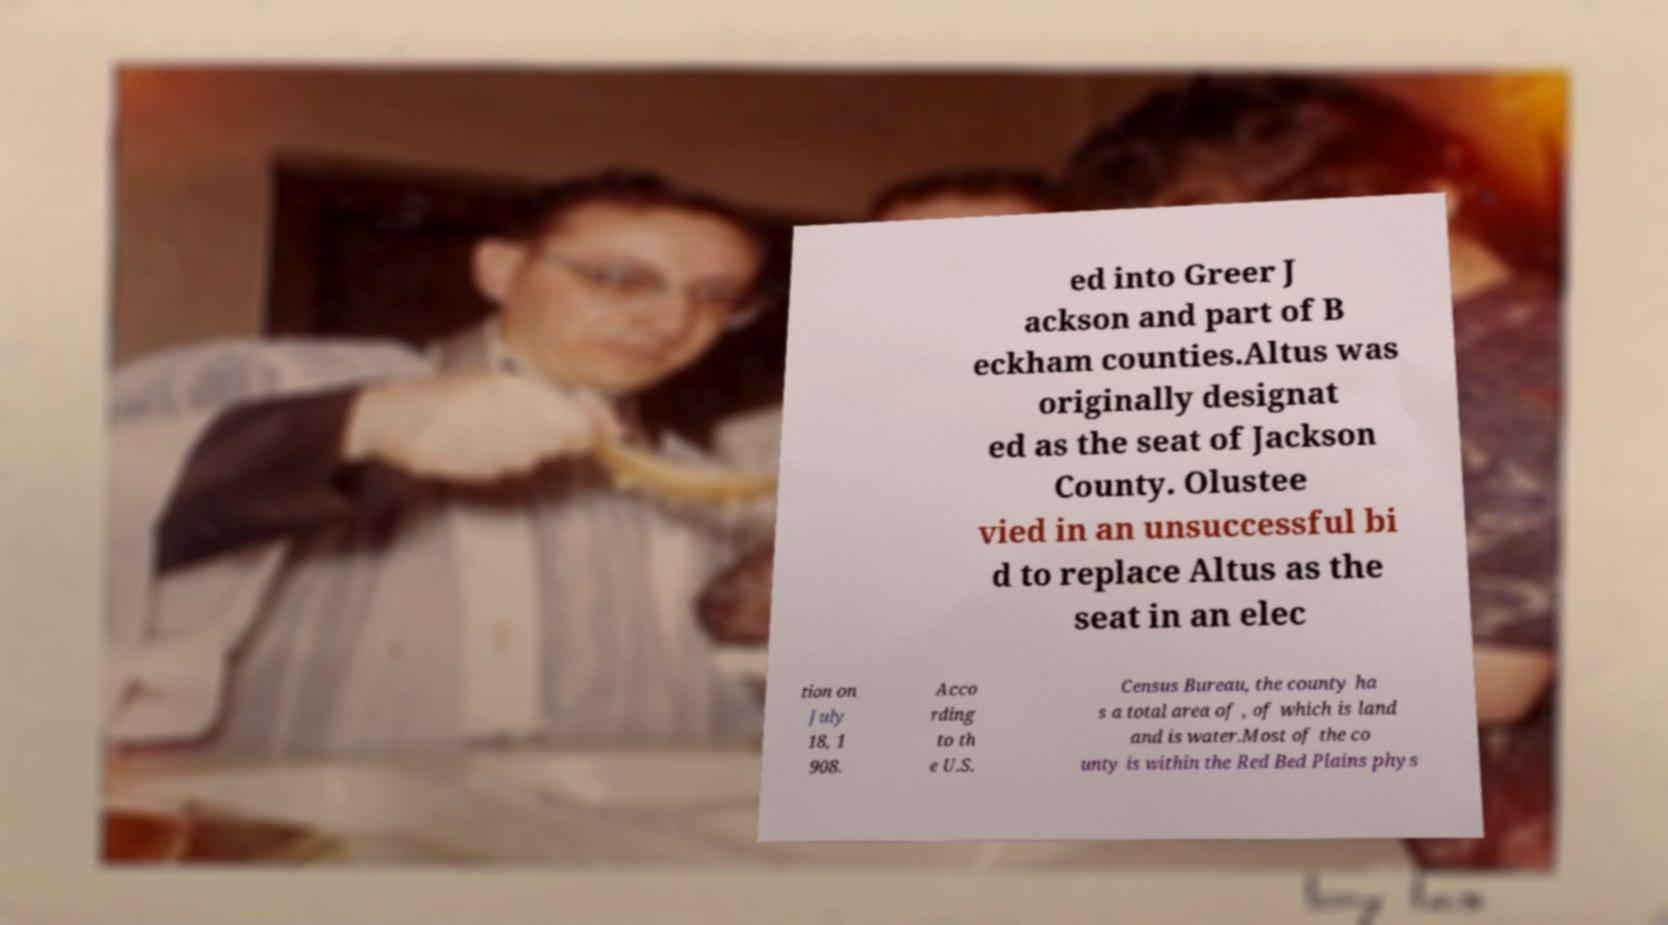I need the written content from this picture converted into text. Can you do that? ed into Greer J ackson and part of B eckham counties.Altus was originally designat ed as the seat of Jackson County. Olustee vied in an unsuccessful bi d to replace Altus as the seat in an elec tion on July 18, 1 908. Acco rding to th e U.S. Census Bureau, the county ha s a total area of , of which is land and is water.Most of the co unty is within the Red Bed Plains phys 